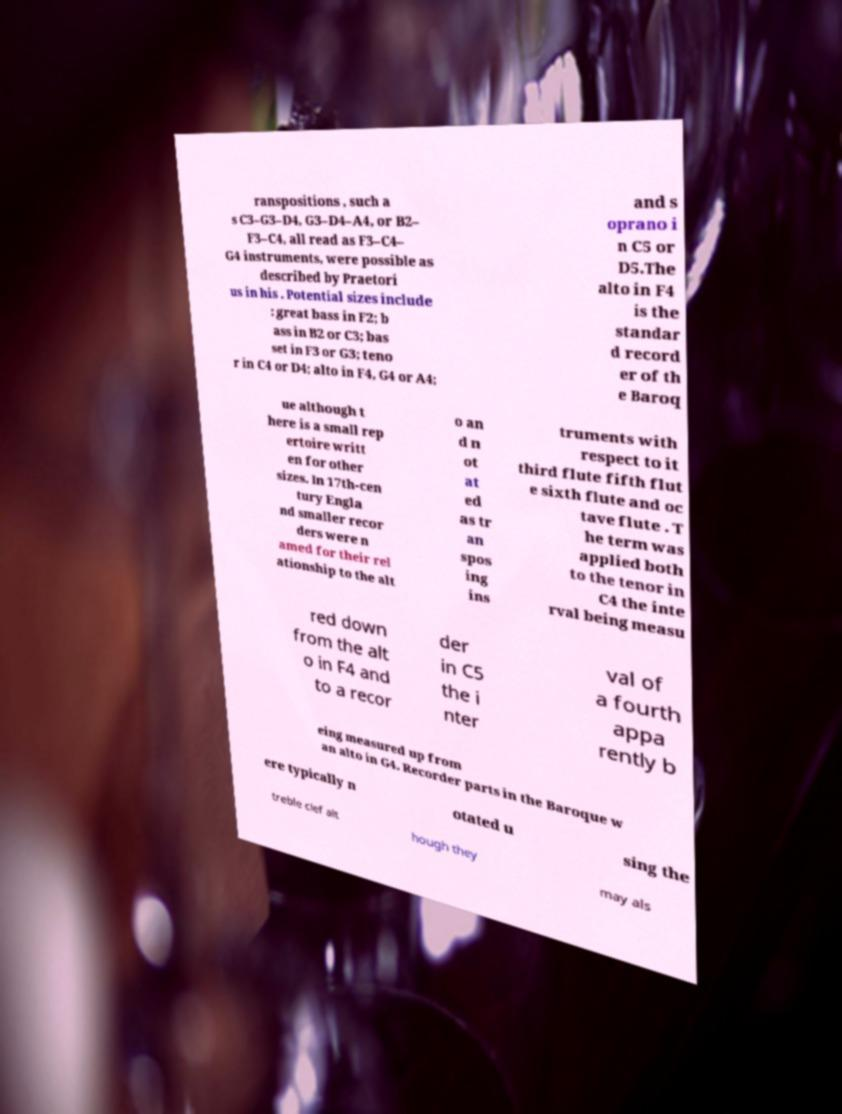Can you read and provide the text displayed in the image?This photo seems to have some interesting text. Can you extract and type it out for me? ranspositions , such a s C3–G3–D4, G3–D4–A4, or B2– F3–C4, all read as F3–C4– G4 instruments, were possible as described by Praetori us in his . Potential sizes include : great bass in F2; b ass in B2 or C3; bas set in F3 or G3; teno r in C4 or D4; alto in F4, G4 or A4; and s oprano i n C5 or D5.The alto in F4 is the standar d record er of th e Baroq ue although t here is a small rep ertoire writt en for other sizes. In 17th-cen tury Engla nd smaller recor ders were n amed for their rel ationship to the alt o an d n ot at ed as tr an spos ing ins truments with respect to it third flute fifth flut e sixth flute and oc tave flute . T he term was applied both to the tenor in C4 the inte rval being measu red down from the alt o in F4 and to a recor der in C5 the i nter val of a fourth appa rently b eing measured up from an alto in G4. Recorder parts in the Baroque w ere typically n otated u sing the treble clef alt hough they may als 